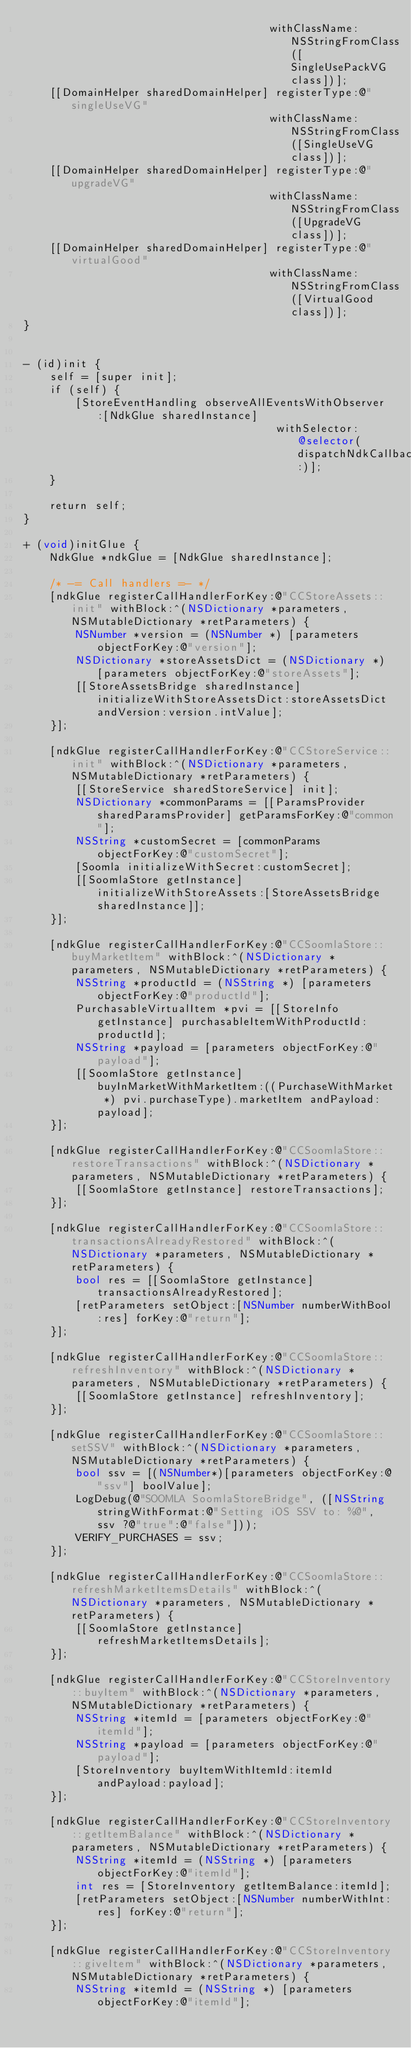Convert code to text. <code><loc_0><loc_0><loc_500><loc_500><_ObjectiveC_>                                      withClassName:NSStringFromClass([SingleUsePackVG class])];
    [[DomainHelper sharedDomainHelper] registerType:@"singleUseVG"
                                      withClassName:NSStringFromClass([SingleUseVG class])];
    [[DomainHelper sharedDomainHelper] registerType:@"upgradeVG"
                                      withClassName:NSStringFromClass([UpgradeVG class])];
    [[DomainHelper sharedDomainHelper] registerType:@"virtualGood"
                                      withClassName:NSStringFromClass([VirtualGood class])];
}


- (id)init {
    self = [super init];
    if (self) {
        [StoreEventHandling observeAllEventsWithObserver:[NdkGlue sharedInstance]
                                       withSelector:@selector(dispatchNdkCallback:)];
    }

    return self;
}

+ (void)initGlue {
    NdkGlue *ndkGlue = [NdkGlue sharedInstance];

    /* -= Call handlers =- */
    [ndkGlue registerCallHandlerForKey:@"CCStoreAssets::init" withBlock:^(NSDictionary *parameters, NSMutableDictionary *retParameters) {
        NSNumber *version = (NSNumber *) [parameters objectForKey:@"version"];
        NSDictionary *storeAssetsDict = (NSDictionary *) [parameters objectForKey:@"storeAssets"];
        [[StoreAssetsBridge sharedInstance] initializeWithStoreAssetsDict:storeAssetsDict andVersion:version.intValue];
    }];

    [ndkGlue registerCallHandlerForKey:@"CCStoreService::init" withBlock:^(NSDictionary *parameters, NSMutableDictionary *retParameters) {
        [[StoreService sharedStoreService] init];
        NSDictionary *commonParams = [[ParamsProvider sharedParamsProvider] getParamsForKey:@"common"];
        NSString *customSecret = [commonParams objectForKey:@"customSecret"];
        [Soomla initializeWithSecret:customSecret];
        [[SoomlaStore getInstance] initializeWithStoreAssets:[StoreAssetsBridge sharedInstance]];
    }];

    [ndkGlue registerCallHandlerForKey:@"CCSoomlaStore::buyMarketItem" withBlock:^(NSDictionary *parameters, NSMutableDictionary *retParameters) {
        NSString *productId = (NSString *) [parameters objectForKey:@"productId"];
        PurchasableVirtualItem *pvi = [[StoreInfo getInstance] purchasableItemWithProductId:productId];
        NSString *payload = [parameters objectForKey:@"payload"];
        [[SoomlaStore getInstance] buyInMarketWithMarketItem:((PurchaseWithMarket *) pvi.purchaseType).marketItem andPayload:payload];
    }];

    [ndkGlue registerCallHandlerForKey:@"CCSoomlaStore::restoreTransactions" withBlock:^(NSDictionary *parameters, NSMutableDictionary *retParameters) {
        [[SoomlaStore getInstance] restoreTransactions];
    }];

    [ndkGlue registerCallHandlerForKey:@"CCSoomlaStore::transactionsAlreadyRestored" withBlock:^(NSDictionary *parameters, NSMutableDictionary *retParameters) {
        bool res = [[SoomlaStore getInstance] transactionsAlreadyRestored];
        [retParameters setObject:[NSNumber numberWithBool:res] forKey:@"return"];
    }];

    [ndkGlue registerCallHandlerForKey:@"CCSoomlaStore::refreshInventory" withBlock:^(NSDictionary *parameters, NSMutableDictionary *retParameters) {
        [[SoomlaStore getInstance] refreshInventory];
    }];

    [ndkGlue registerCallHandlerForKey:@"CCSoomlaStore::setSSV" withBlock:^(NSDictionary *parameters, NSMutableDictionary *retParameters) {
        bool ssv = [(NSNumber*)[parameters objectForKey:@"ssv"] boolValue];
        LogDebug(@"SOOMLA SoomlaStoreBridge", ([NSString stringWithFormat:@"Setting iOS SSV to: %@", ssv ?@"true":@"false"]));
        VERIFY_PURCHASES = ssv;
    }];

    [ndkGlue registerCallHandlerForKey:@"CCSoomlaStore::refreshMarketItemsDetails" withBlock:^(NSDictionary *parameters, NSMutableDictionary *retParameters) {
        [[SoomlaStore getInstance] refreshMarketItemsDetails];
    }];

    [ndkGlue registerCallHandlerForKey:@"CCStoreInventory::buyItem" withBlock:^(NSDictionary *parameters, NSMutableDictionary *retParameters) {
        NSString *itemId = [parameters objectForKey:@"itemId"];
        NSString *payload = [parameters objectForKey:@"payload"];
        [StoreInventory buyItemWithItemId:itemId andPayload:payload];
    }];

    [ndkGlue registerCallHandlerForKey:@"CCStoreInventory::getItemBalance" withBlock:^(NSDictionary *parameters, NSMutableDictionary *retParameters) {
        NSString *itemId = (NSString *) [parameters objectForKey:@"itemId"];
        int res = [StoreInventory getItemBalance:itemId];
        [retParameters setObject:[NSNumber numberWithInt:res] forKey:@"return"];
    }];

    [ndkGlue registerCallHandlerForKey:@"CCStoreInventory::giveItem" withBlock:^(NSDictionary *parameters, NSMutableDictionary *retParameters) {
        NSString *itemId = (NSString *) [parameters objectForKey:@"itemId"];</code> 